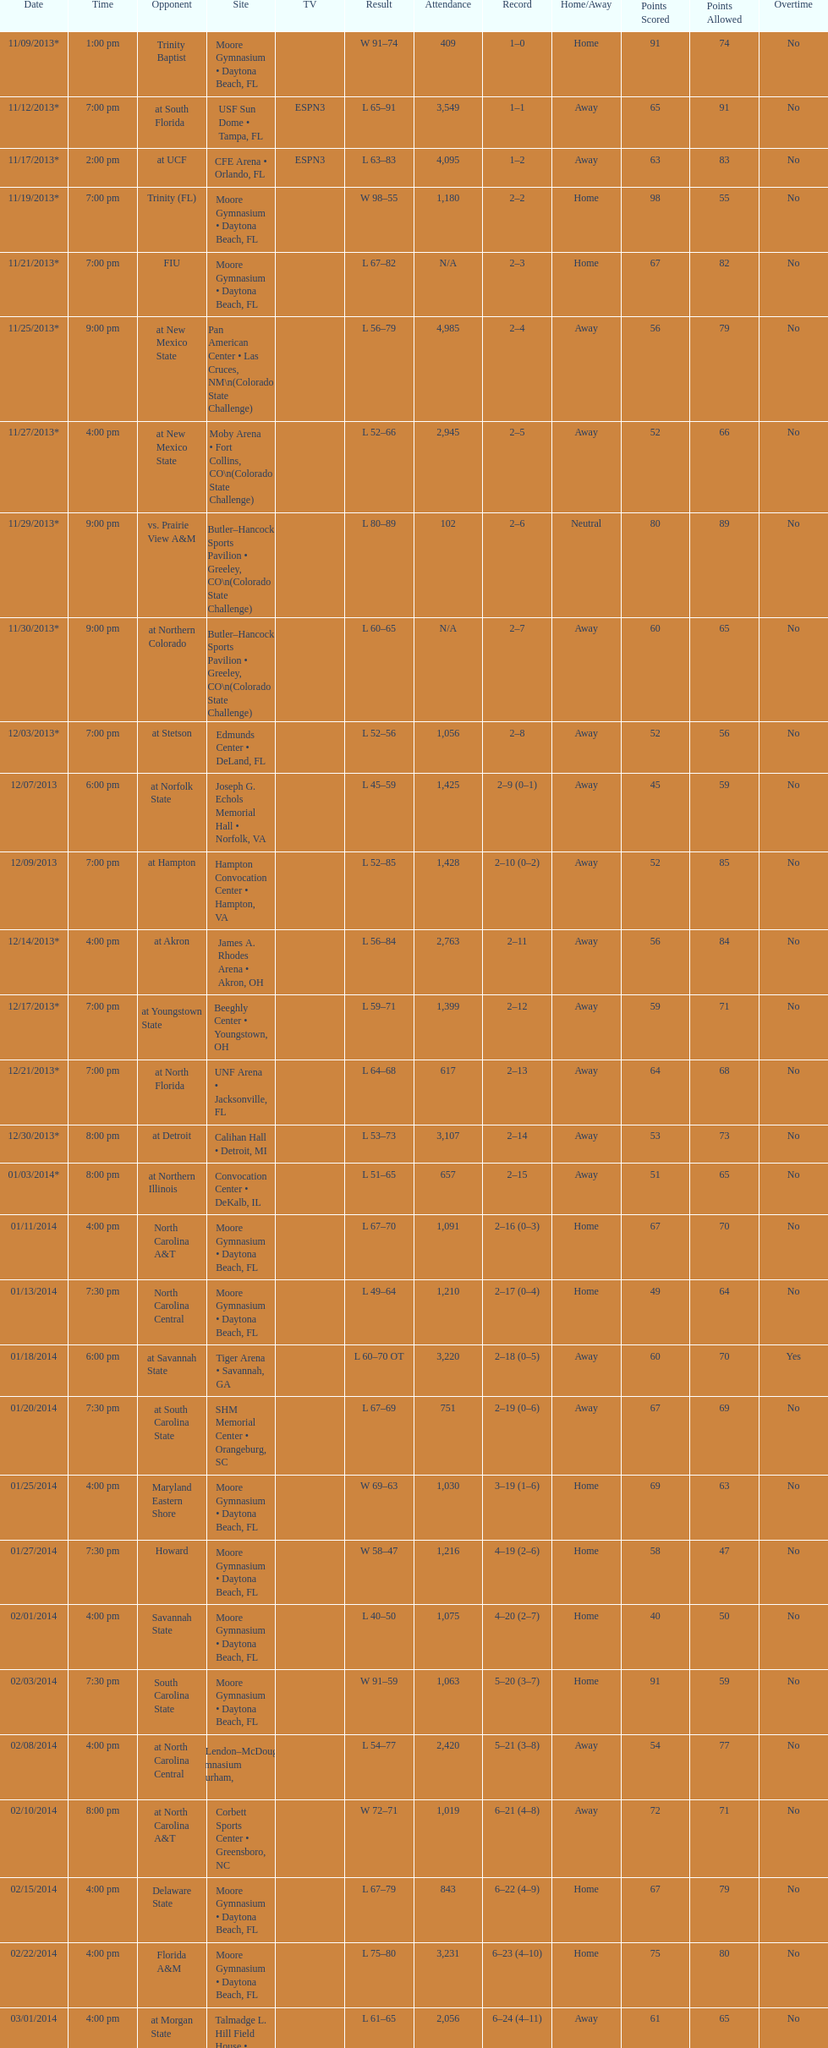How many games did the wildcats play in daytona beach, fl? 11. 